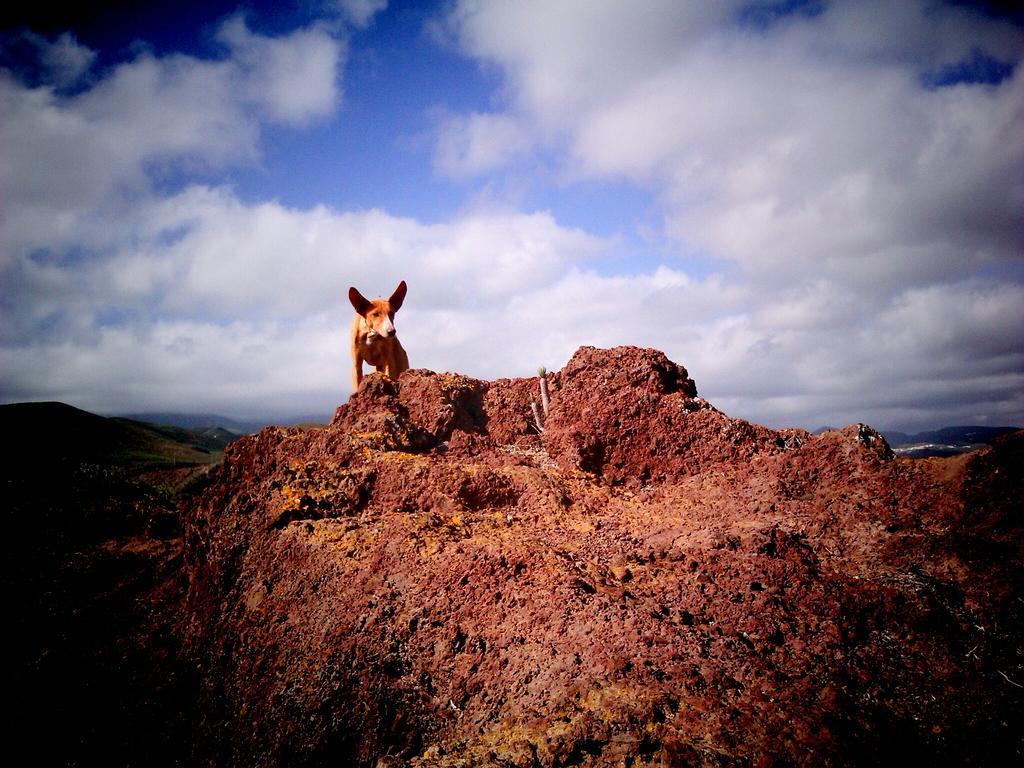Describe this image in one or two sentences. In this image there is a dog standing on a rock, in the background of the image there are mountains, at the top of the image there are clouds in the sky. 